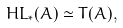Convert formula to latex. <formula><loc_0><loc_0><loc_500><loc_500>H L _ { * } ( A ) \simeq T ( A ) ,</formula> 